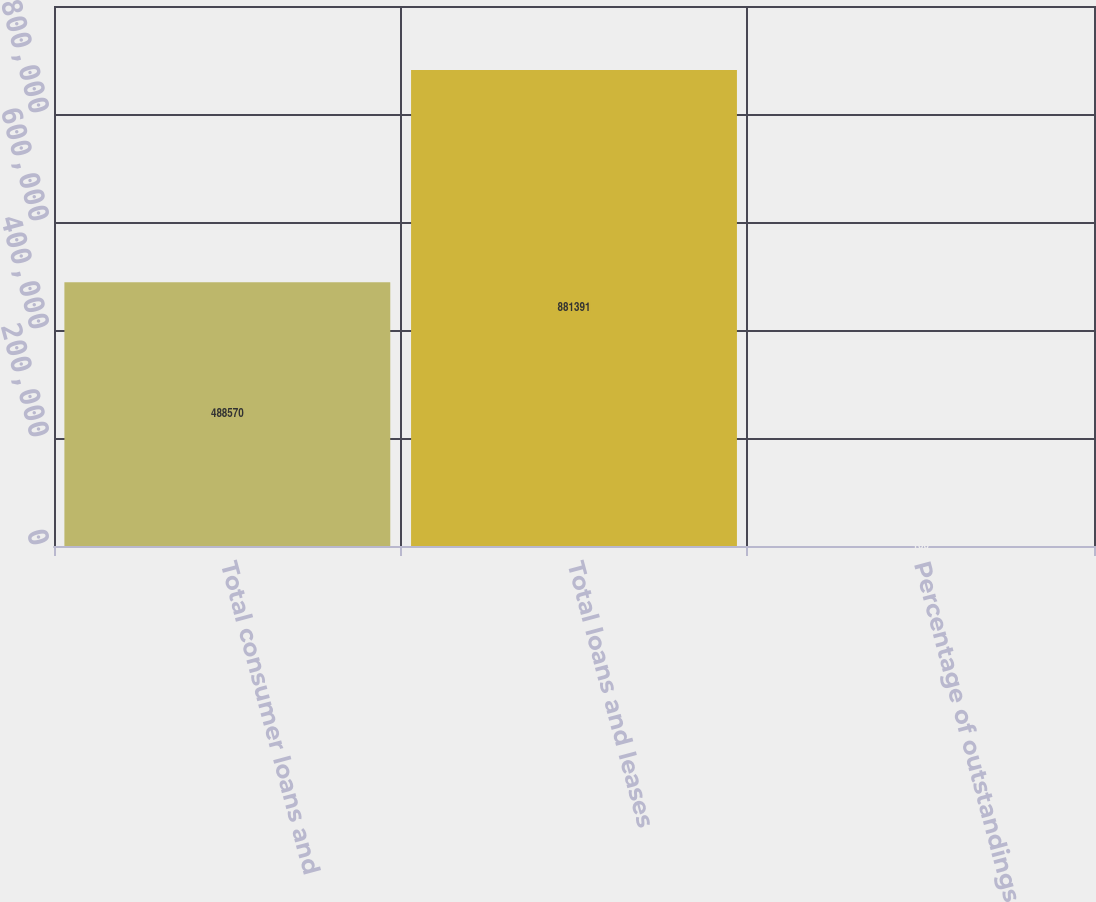<chart> <loc_0><loc_0><loc_500><loc_500><bar_chart><fcel>Total consumer loans and<fcel>Total loans and leases<fcel>Percentage of outstandings<nl><fcel>488570<fcel>881391<fcel>100<nl></chart> 